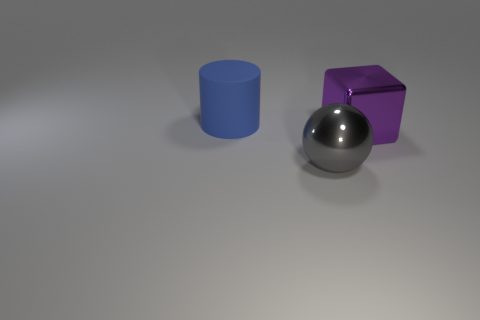Add 3 blue rubber cylinders. How many objects exist? 6 Subtract 1 spheres. How many spheres are left? 0 Subtract all spheres. How many objects are left? 2 Subtract all small green rubber blocks. Subtract all blue matte things. How many objects are left? 2 Add 2 big gray metal objects. How many big gray metal objects are left? 3 Add 2 large gray metallic objects. How many large gray metallic objects exist? 3 Subtract 1 gray balls. How many objects are left? 2 